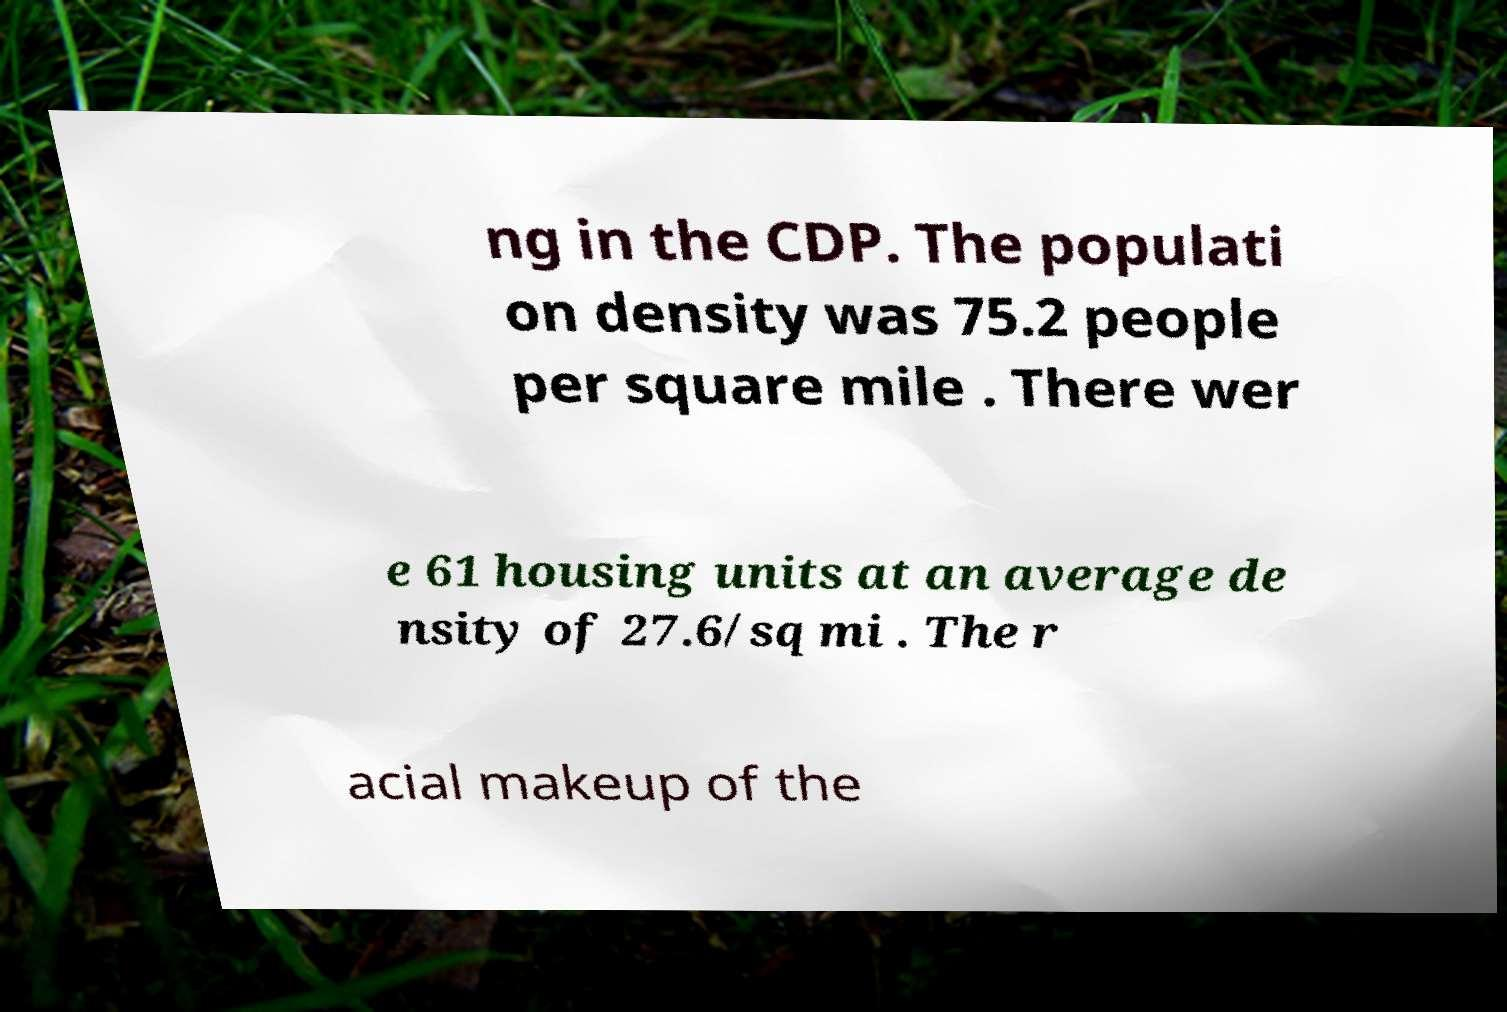Please read and relay the text visible in this image. What does it say? ng in the CDP. The populati on density was 75.2 people per square mile . There wer e 61 housing units at an average de nsity of 27.6/sq mi . The r acial makeup of the 